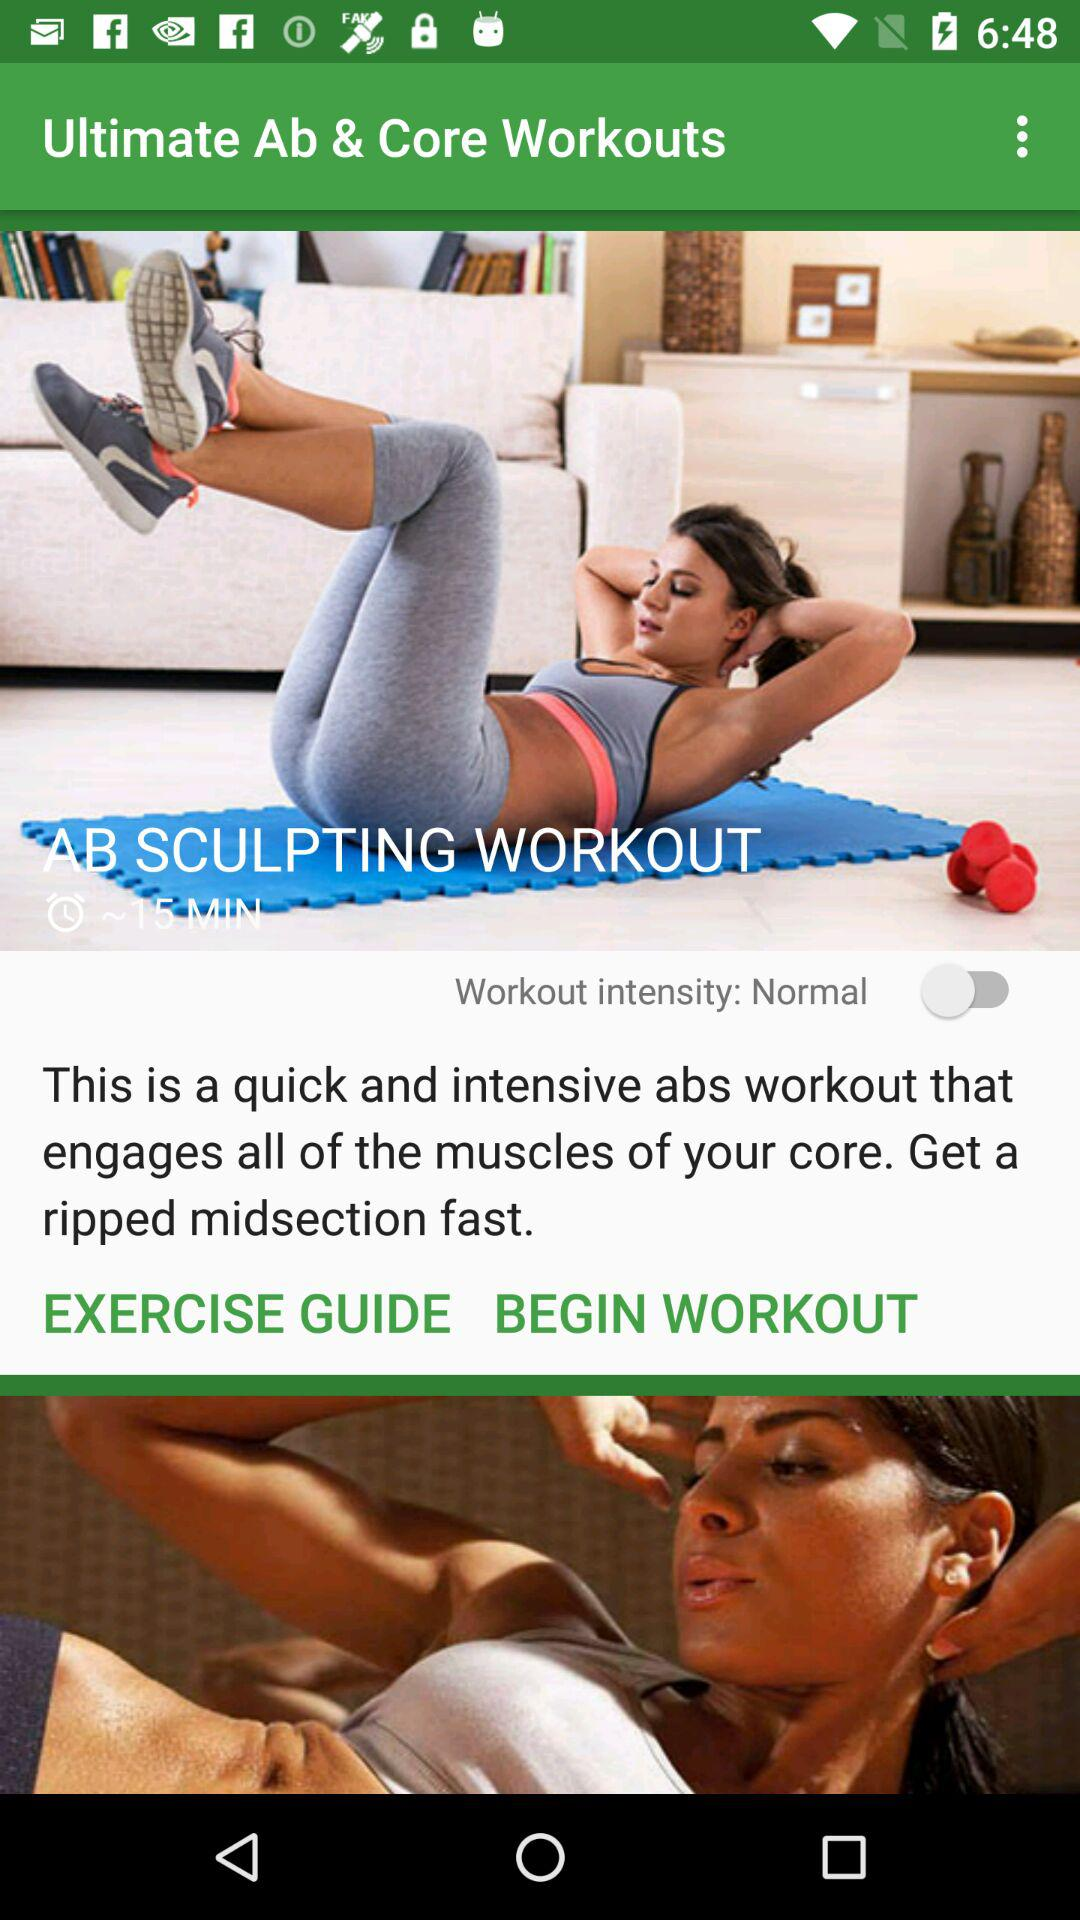What is the workout intensity? The workout intensity is normal. 